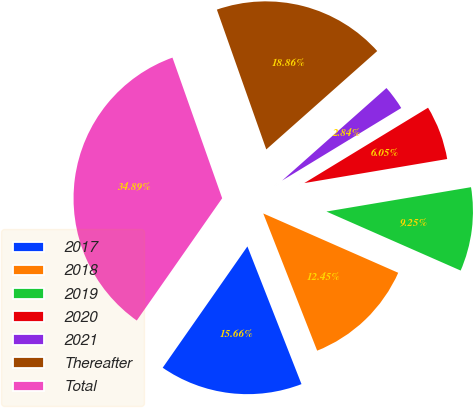Convert chart. <chart><loc_0><loc_0><loc_500><loc_500><pie_chart><fcel>2017<fcel>2018<fcel>2019<fcel>2020<fcel>2021<fcel>Thereafter<fcel>Total<nl><fcel>15.66%<fcel>12.45%<fcel>9.25%<fcel>6.05%<fcel>2.84%<fcel>18.86%<fcel>34.89%<nl></chart> 